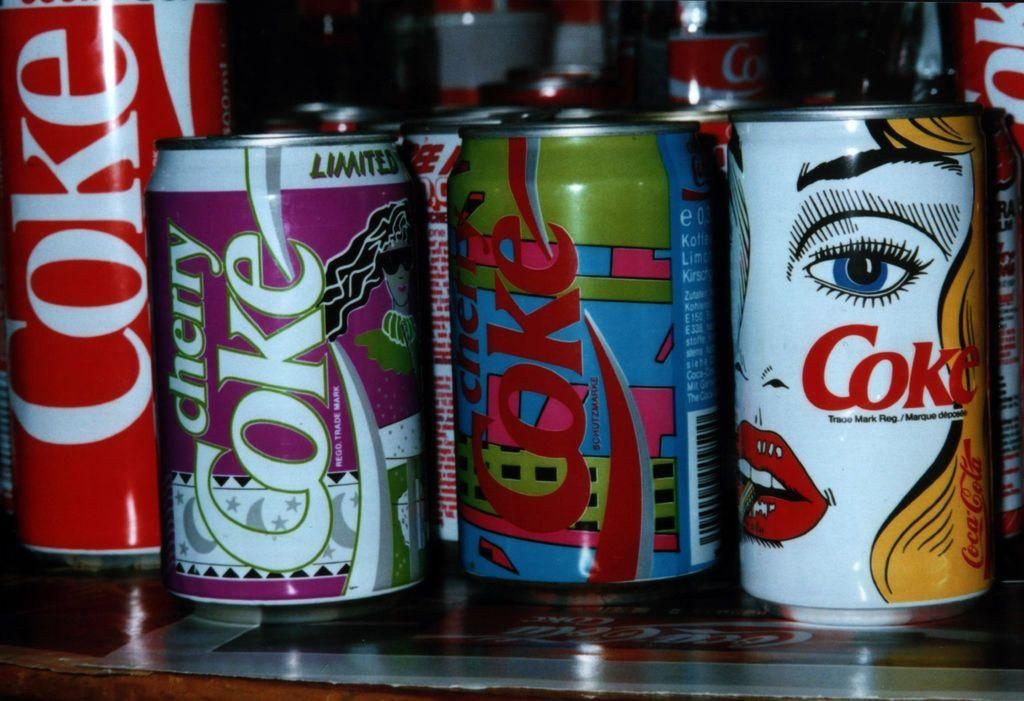<image>
Describe the image concisely. a collection of COKE soda cans that are artistic. 